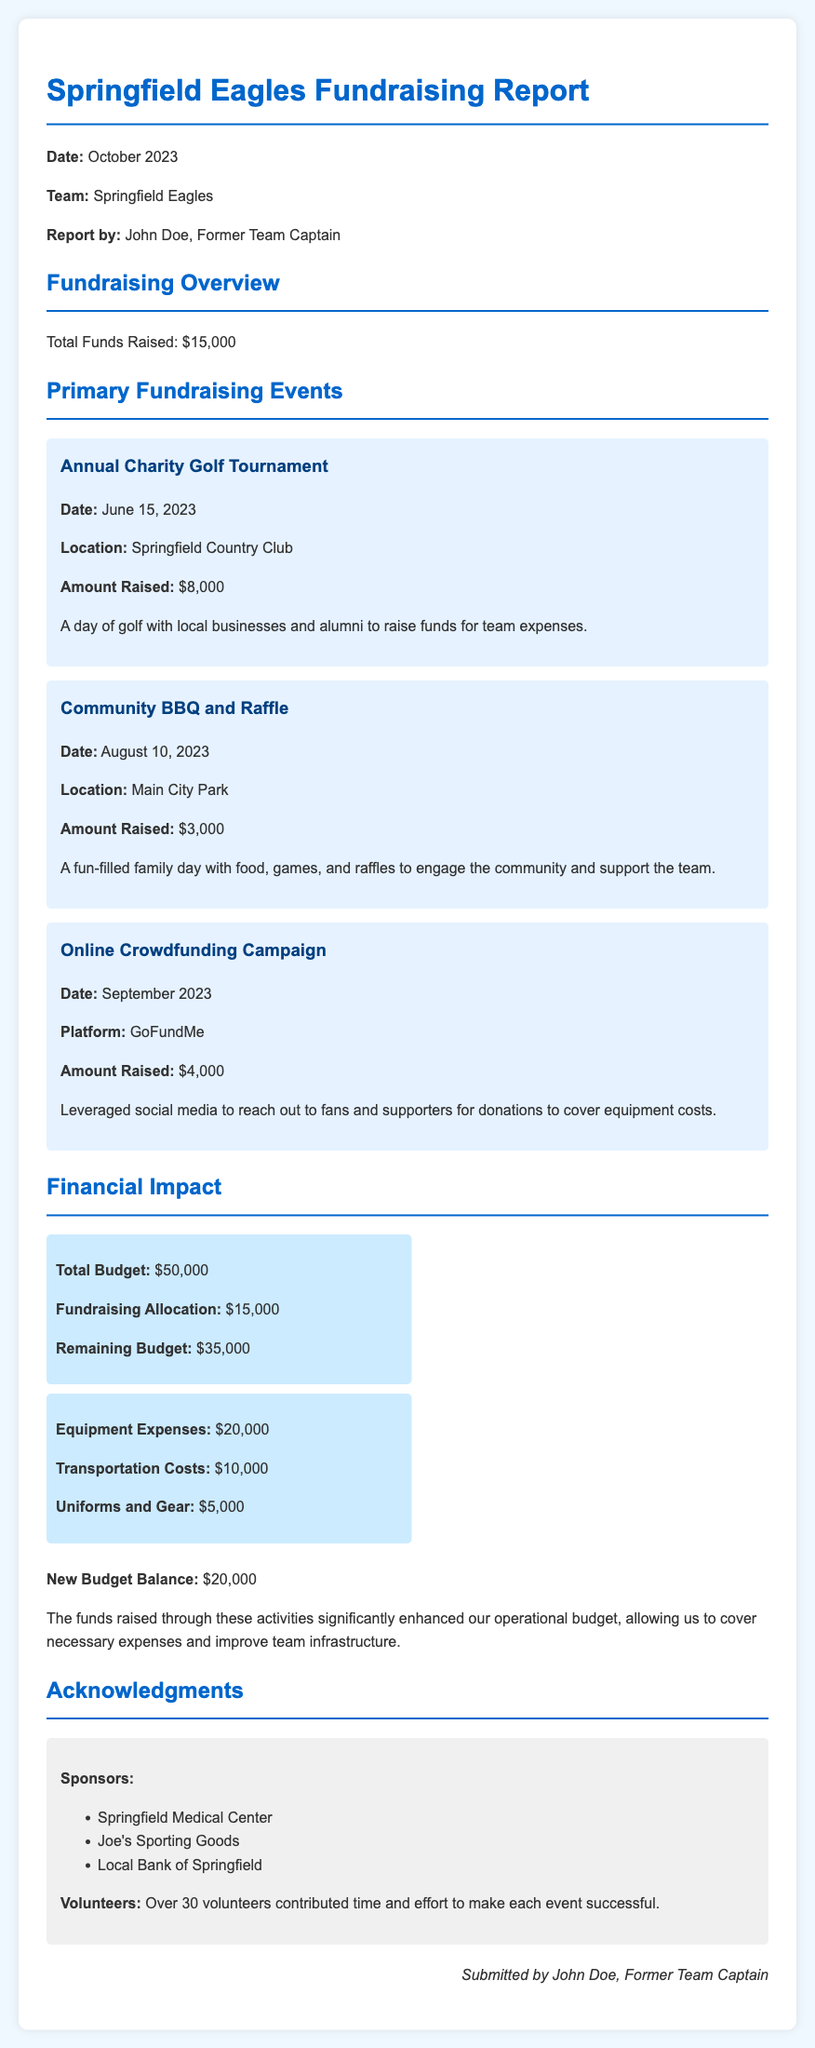what was the total amount raised? The total amount raised is specified in the fundraising overview section of the report.
Answer: $15,000 when was the Annual Charity Golf Tournament held? The date of the Annual Charity Golf Tournament is mentioned in the event description.
Answer: June 15, 2023 where did the Community BBQ and Raffle take place? The location of the Community BBQ and Raffle is provided in the event details.
Answer: Main City Park how much was allocated from the fundraising efforts to the budget? The fundraising allocation is indicated in the financial impact section of the report.
Answer: $15,000 what are the total equipment expenses listed? The equipment expenses can be found in the financial items detailing costs for team operations.
Answer: $20,000 what is the new budget balance after fundraising? The new budget balance is reported in the financial summary of the document.
Answer: $20,000 how many volunteers helped with the events? The number of volunteers is stated in the acknowledgments section.
Answer: Over 30 volunteers what type of events contributed to the fundraising? The fundraising overview mentions specific types of events that raised funds.
Answer: Charity Golf Tournament, Community BBQ, Online Crowdfunding who contributed time and effort to make the events successful? The acknowledgments section highlights who contributed towards the successful events.
Answer: Volunteers 